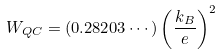Convert formula to latex. <formula><loc_0><loc_0><loc_500><loc_500>W _ { Q C } = ( 0 . 2 8 2 0 3 \cdots ) \left ( \frac { k _ { B } } { e } \right ) ^ { 2 }</formula> 